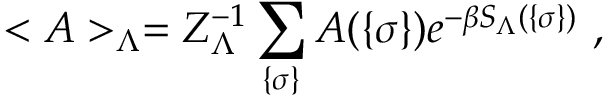Convert formula to latex. <formula><loc_0><loc_0><loc_500><loc_500>< A > _ { \Lambda } = Z _ { \Lambda } ^ { - 1 } \sum _ { \{ \sigma \} } A ( \{ \sigma \} ) e ^ { - \beta S _ { \Lambda } ( \{ \sigma \} ) } ,</formula> 